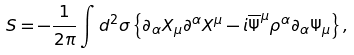Convert formula to latex. <formula><loc_0><loc_0><loc_500><loc_500>S = - \frac { 1 } { 2 \pi } \int d ^ { 2 } \sigma \left \{ \partial _ { \alpha } X _ { \mu } \partial ^ { \alpha } X ^ { \mu } - i \overline { \Psi } ^ { \mu } \rho ^ { \alpha } \partial _ { \alpha } \Psi _ { \mu } \right \} ,</formula> 